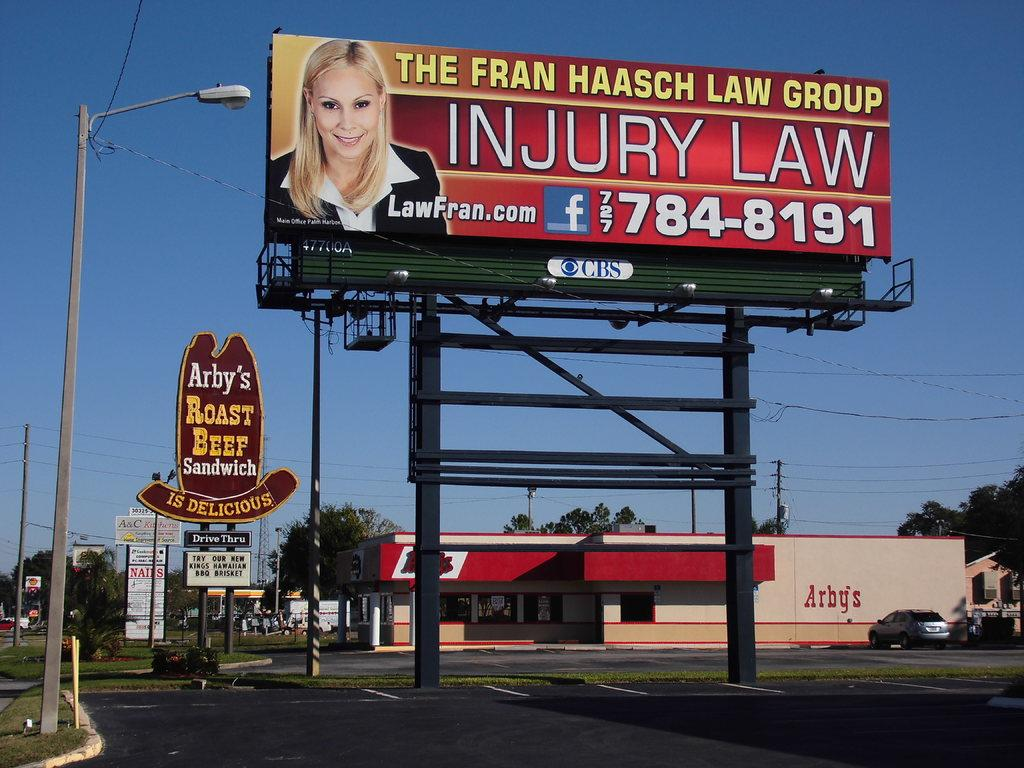<image>
Render a clear and concise summary of the photo. a billboard for The Fran Haasch Law Group above a parking lot 